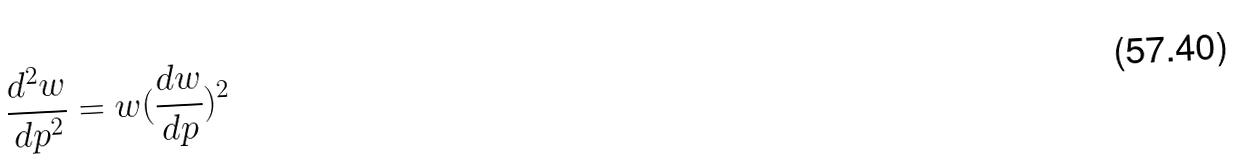<formula> <loc_0><loc_0><loc_500><loc_500>\frac { d ^ { 2 } w } { d p ^ { 2 } } = w ( \frac { d w } { d p } ) ^ { 2 }</formula> 